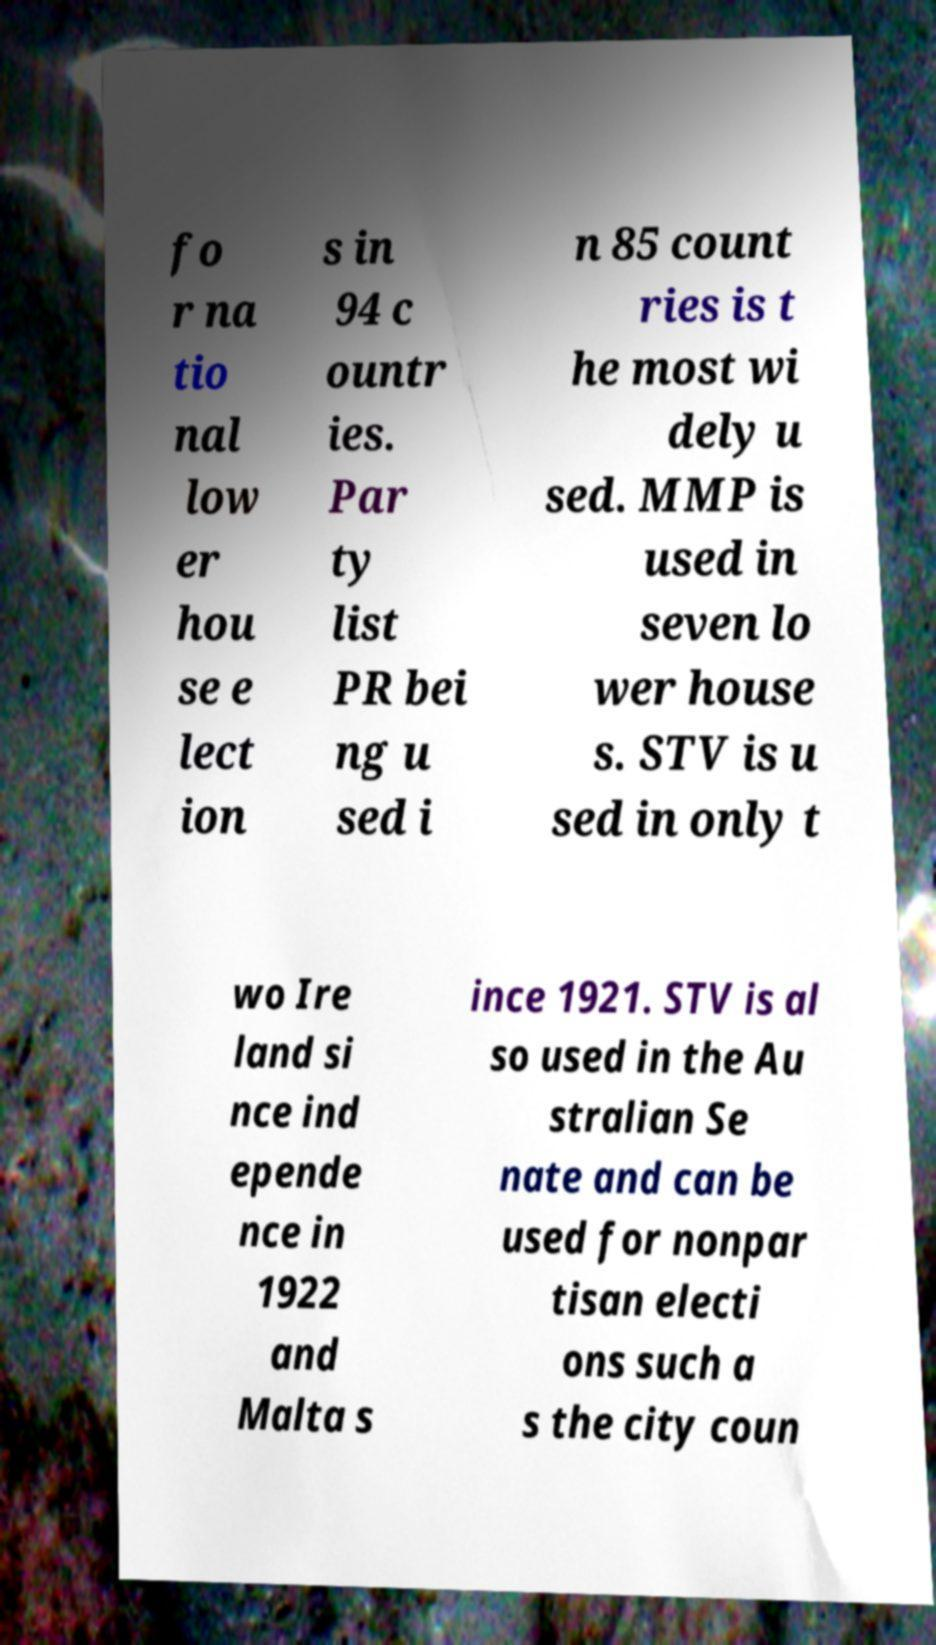I need the written content from this picture converted into text. Can you do that? fo r na tio nal low er hou se e lect ion s in 94 c ountr ies. Par ty list PR bei ng u sed i n 85 count ries is t he most wi dely u sed. MMP is used in seven lo wer house s. STV is u sed in only t wo Ire land si nce ind epende nce in 1922 and Malta s ince 1921. STV is al so used in the Au stralian Se nate and can be used for nonpar tisan electi ons such a s the city coun 